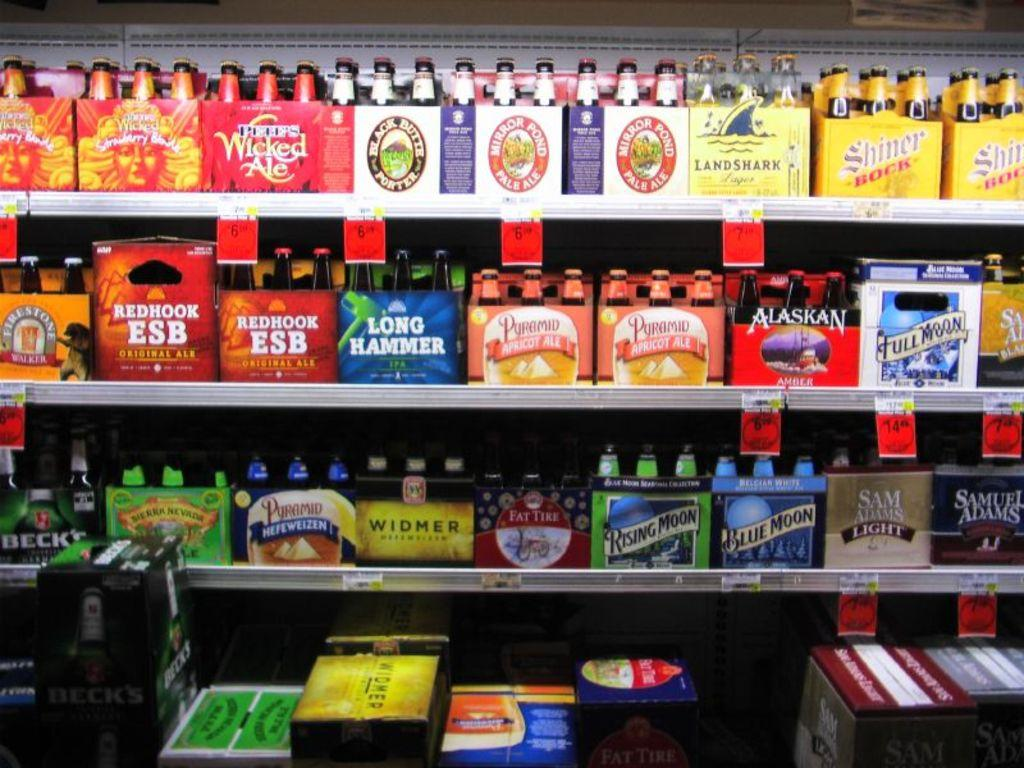<image>
Render a clear and concise summary of the photo. beer isle at store with sam adams light, full moon, alaskan are on sale 